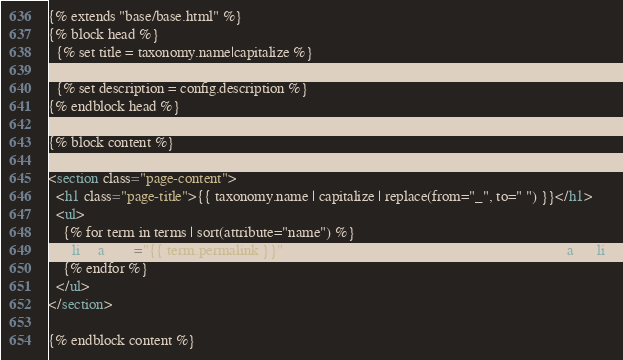<code> <loc_0><loc_0><loc_500><loc_500><_HTML_>{% extends "base/base.html" %}
{% block head %}
  {% set title = taxonomy.name|capitalize %}
  {% set title = title ~ " - " ~ config.title %}
  {% set description = config.description %}
{% endblock head %}

{% block content %}

<section class="page-content">
  <h1 class="page-title">{{ taxonomy.name | capitalize | replace(from="_", to=" ") }}</h1>
  <ul>
    {% for term in terms | sort(attribute="name") %}
    <li><a href="{{ term.permalink }}">{{ term.name }} ({{ term.pages | length }})</a></li>
    {% endfor %}
  </ul>
</section>

{% endblock content %}
</code> 